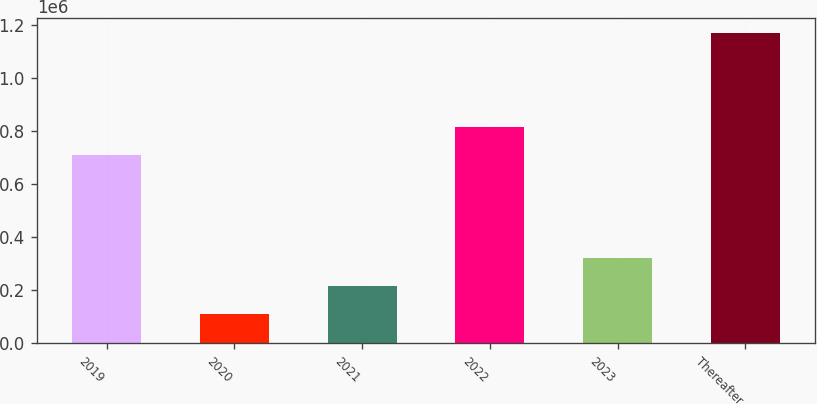Convert chart to OTSL. <chart><loc_0><loc_0><loc_500><loc_500><bar_chart><fcel>2019<fcel>2020<fcel>2021<fcel>2022<fcel>2023<fcel>Thereafter<nl><fcel>711147<fcel>111562<fcel>217374<fcel>816959<fcel>323187<fcel>1.16968e+06<nl></chart> 